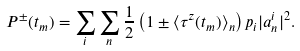Convert formula to latex. <formula><loc_0><loc_0><loc_500><loc_500>P ^ { \pm } ( t _ { m } ) = \sum _ { i } \sum _ { n } \frac { 1 } { 2 } \left ( 1 \pm \langle \tau ^ { z } ( t _ { m } ) \rangle _ { n } \right ) p _ { i } | a _ { n } ^ { i } | ^ { 2 } .</formula> 